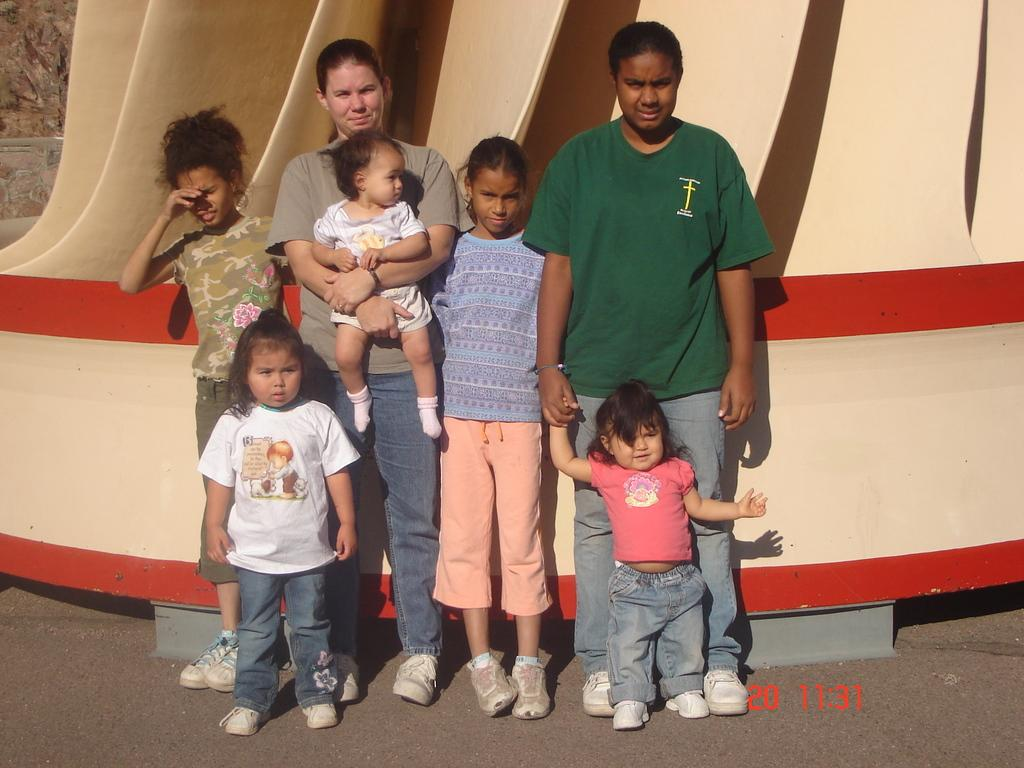What is happening in the image? People are standing in the image. Can you describe the actions of one of the individuals? There is a person holding a baby in the image. What additional information is provided at the bottom of the image? Time is mentioned at the bottom of the image. What type of loaf is being shared among the people in the image? There is no loaf present in the image. Can you hear the owl hooting in the background of the image? There is no owl or sound present in the image. 